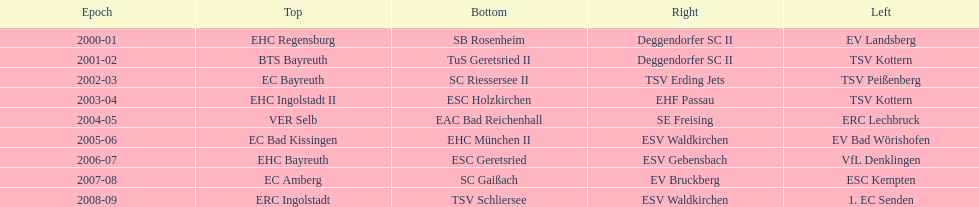What is the number of seasons covered in the table? 9. 